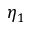<formula> <loc_0><loc_0><loc_500><loc_500>\eta _ { 1 }</formula> 